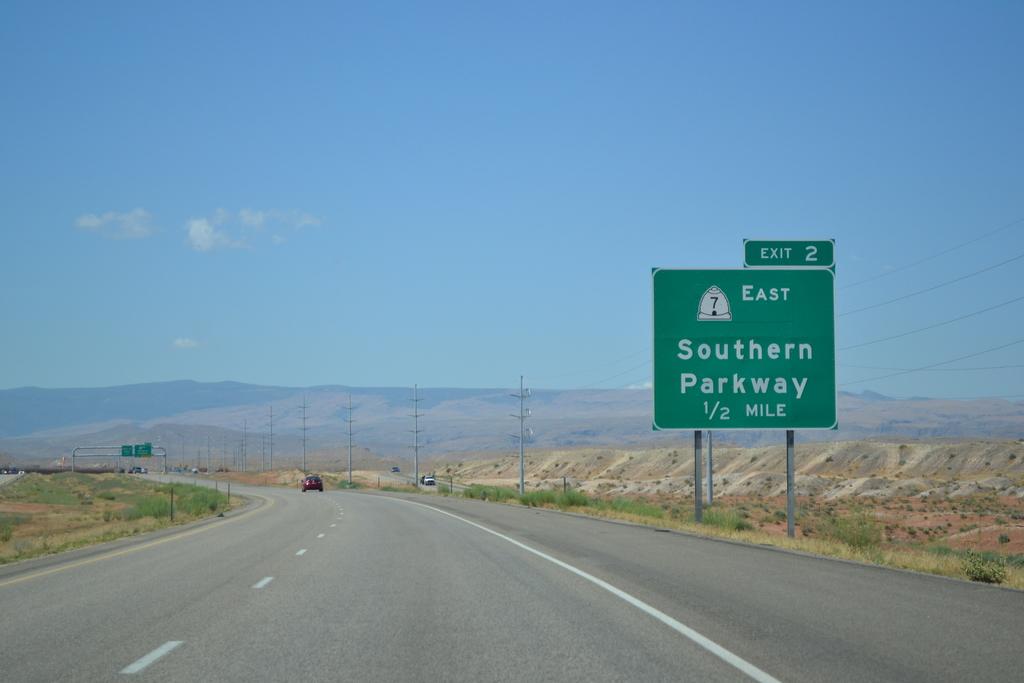What is the next exit number?
Keep it short and to the point. 2. How far away is the exit?
Your answer should be very brief. 1/2 mile. 